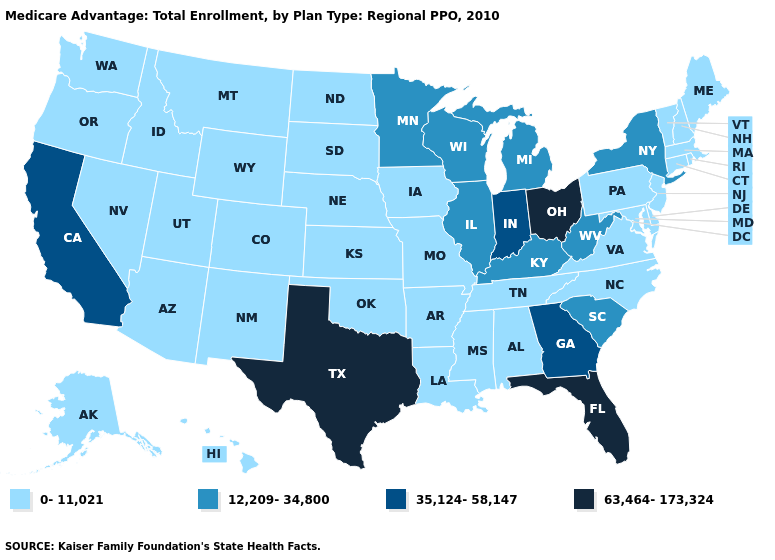What is the value of Alabama?
Quick response, please. 0-11,021. What is the value of Montana?
Be succinct. 0-11,021. Is the legend a continuous bar?
Quick response, please. No. Which states hav the highest value in the West?
Write a very short answer. California. Does Alaska have the same value as Minnesota?
Be succinct. No. Name the states that have a value in the range 63,464-173,324?
Be succinct. Florida, Ohio, Texas. Does Florida have the highest value in the South?
Be succinct. Yes. Does North Dakota have the same value as Nevada?
Short answer required. Yes. Name the states that have a value in the range 35,124-58,147?
Concise answer only. California, Georgia, Indiana. Name the states that have a value in the range 35,124-58,147?
Be succinct. California, Georgia, Indiana. Name the states that have a value in the range 12,209-34,800?
Concise answer only. Illinois, Kentucky, Michigan, Minnesota, New York, South Carolina, Wisconsin, West Virginia. Does West Virginia have the highest value in the South?
Give a very brief answer. No. What is the lowest value in the USA?
Give a very brief answer. 0-11,021. Does the map have missing data?
Keep it brief. No. 